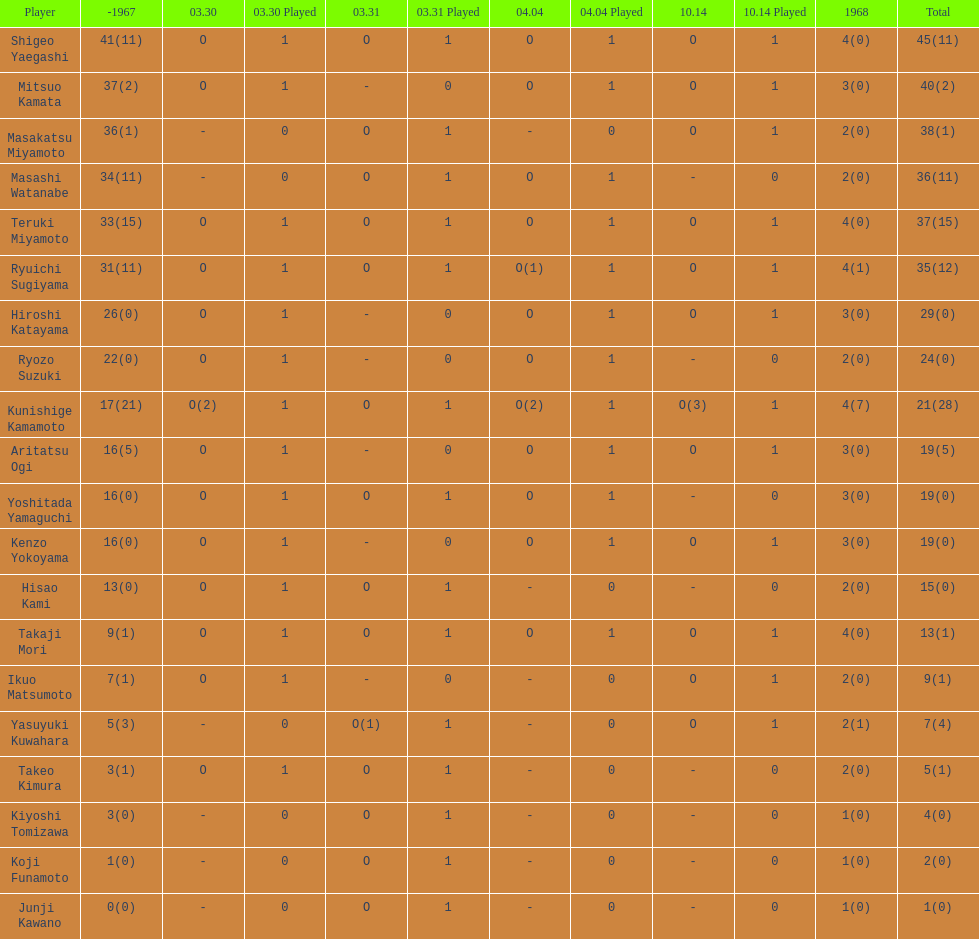How many players made an appearance that year? 20. 